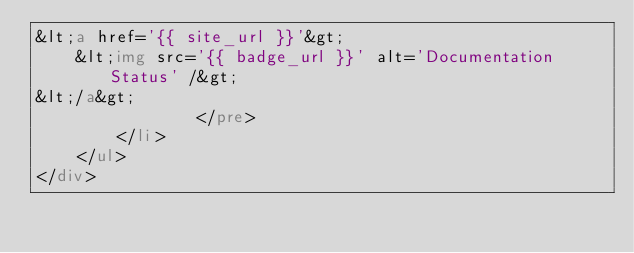<code> <loc_0><loc_0><loc_500><loc_500><_HTML_>&lt;a href='{{ site_url }}'&gt;
    &lt;img src='{{ badge_url }}' alt='Documentation Status' /&gt;
&lt;/a&gt;
                </pre>
        </li>
    </ul>
</div>
</code> 